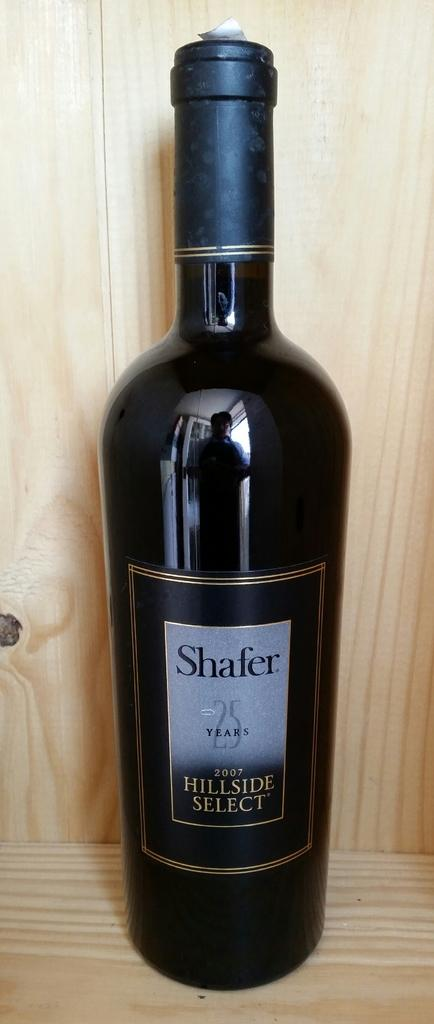<image>
Share a concise interpretation of the image provided. Bottle of 2007 Shafer Hillside Select wine on a wooden shelf. 